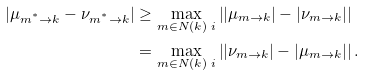<formula> <loc_0><loc_0><loc_500><loc_500>\left | \mu _ { m ^ { ^ { * } } \rightarrow k } - \nu _ { m ^ { ^ { * } } \rightarrow k } \right | & \geq \max _ { m \in N ( k ) \ i } \left | | \mu _ { m \rightarrow k } | - | \nu _ { m \rightarrow k } | \right | \\ & = \max _ { m \in N ( k ) \ i } \left | | \nu _ { m \rightarrow k } | - | \mu _ { m \rightarrow k } | \right | .</formula> 